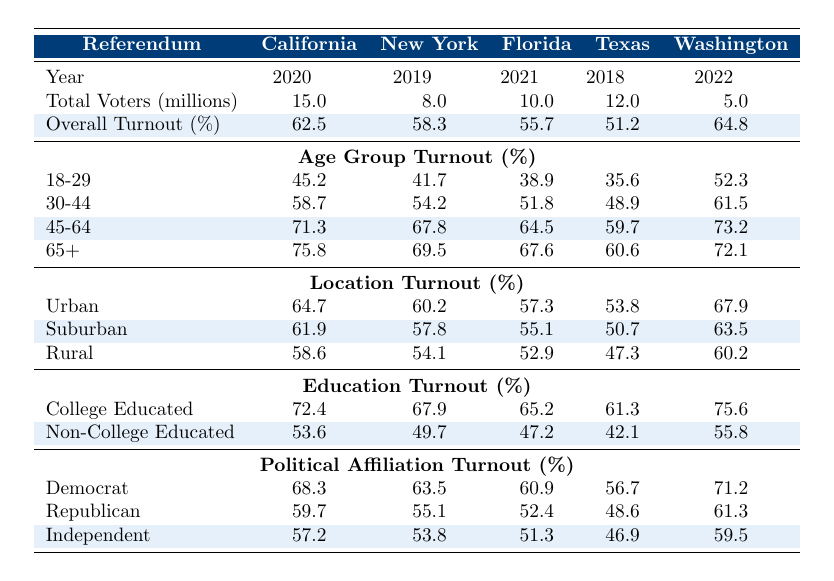What is the turnout percentage for the California Clean Energy Act? The table shows the overall turnout percentage for the California Clean Energy Act is listed in the "Overall Turnout (%)" row under the California column for the year 2020, which is 62.5%.
Answer: 62.5% Which referendum had the highest turnout among the 65+ age group? By examining the "65+" row in the Age Group Turnout section, we find the highest percentage for the 65+ age group, which is 75.8% associated with the California Clean Energy Act.
Answer: 75.8% What was the turnout percentage for non-college educated voters for the Florida Everglades Protection Bill? The table presents the non-college educated turnout percentage for the Florida Everglades Protection Bill in the "Non-College Educated" row, which is 47.2%.
Answer: 47.2% Which demographic had the lowest turnout in the Texas Renewable Energy Mandate? Checking the turnout percentages for different demographics within the Texas column, the 18-29 age group shows the lowest turnout of 35.6%.
Answer: 35.6% What is the average turnout percentage for rural voters across all referendums? To calculate the average, we sum the rural turnout values (58.6 + 54.1 + 52.9 + 47.3 + 60.2 = 273.1) and divide by the total number of referendums (5) yielding 273.1/5 = 54.62%.
Answer: 54.62% Is the turnout percentage for the New York Plastic Ban Initiative higher among Democrats than among Republicans? The turnout percentages show that Democrats had a turnout of 63.5% and Republicans 55.1% for the New York Plastic Ban Initiative, confirming that 63.5% is greater than 55.1%.
Answer: Yes Which demographic had a higher turnout for the Washington State Carbon Tax Proposal: college educated or non-college educated? Comparing the "College Educated" (75.6%) and "Non-College Educated" (55.8%) turnout percentages for Washington, college educated voters had a higher turnout.
Answer: College educated What is the difference in turnout percentage between the 30-44 age group and the 45-64 age group for the California Clean Energy Act? The turnout percentage for the 30-44 age group is 58.7%, and for the 45-64 age group, it is 71.3%. Calculating the difference (71.3 - 58.7) gives us 12.6%.
Answer: 12.6% For which location category was turnout lowest in the overall percentages for the Florida Everglades Protection Bill? Looking at the location turnout percentages, rural turnout is 52.9%, which is lower than urban (57.3%) and suburban (55.1%) turnouts.
Answer: Rural What is the trend in voter turnout percentages for the 18-29 age group across the referendums? The percentages for the 18-29 age group are 45.2%, 41.7%, 38.9%, 35.6%, and 52.3%, indicating a decrease from the California Clean Energy Act to the Texas Renewable Energy Mandate, then an increase for the Washington State Carbon Tax Proposal.
Answer: Decreasing then increasing 